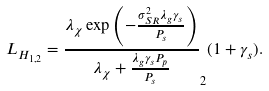Convert formula to latex. <formula><loc_0><loc_0><loc_500><loc_500>L _ { H _ { 1 , 2 } } = \frac { \lambda _ { \chi } \exp \left ( - \frac { \sigma _ { S R } ^ { 2 } \lambda _ { g } \gamma _ { s } } { P _ { s } } \right ) } { \lambda _ { \chi } + \frac { \lambda _ { g } \gamma _ { s } P _ { p } } { P _ { s } } } _ { 2 } ( 1 + \gamma _ { s } ) .</formula> 